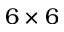Convert formula to latex. <formula><loc_0><loc_0><loc_500><loc_500>6 \times 6</formula> 